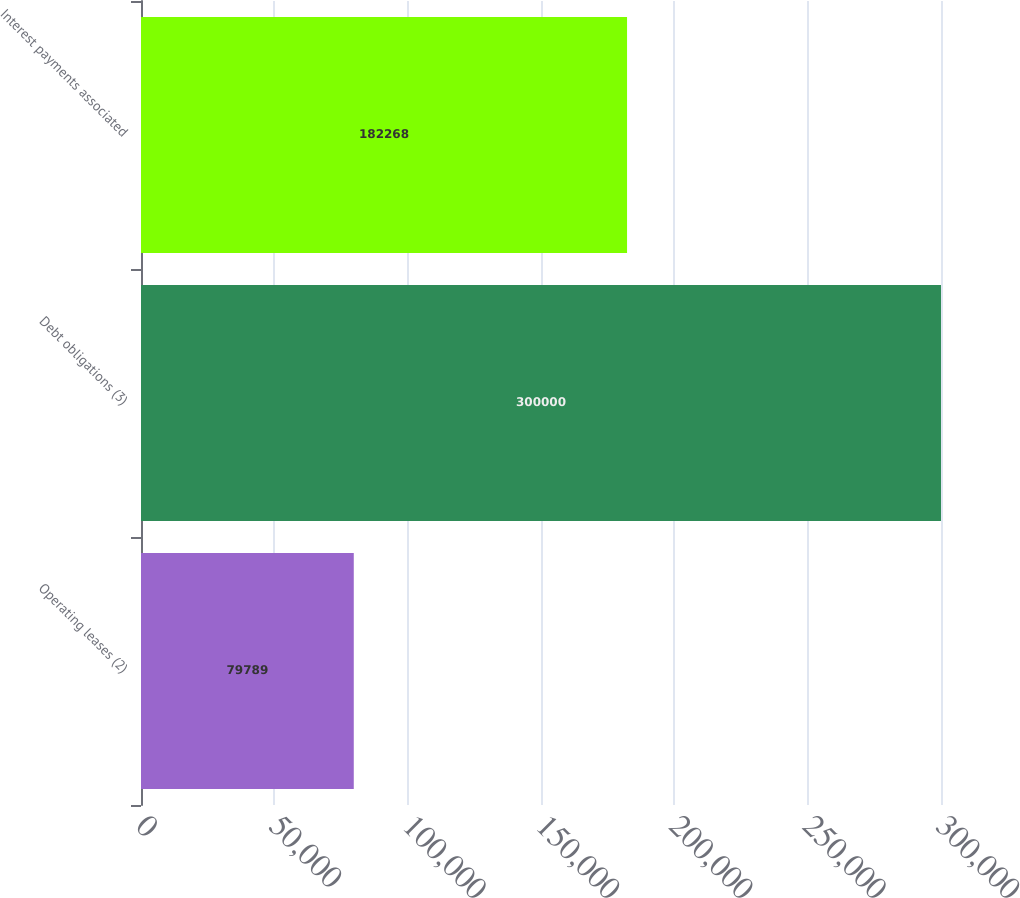Convert chart. <chart><loc_0><loc_0><loc_500><loc_500><bar_chart><fcel>Operating leases (2)<fcel>Debt obligations (3)<fcel>Interest payments associated<nl><fcel>79789<fcel>300000<fcel>182268<nl></chart> 